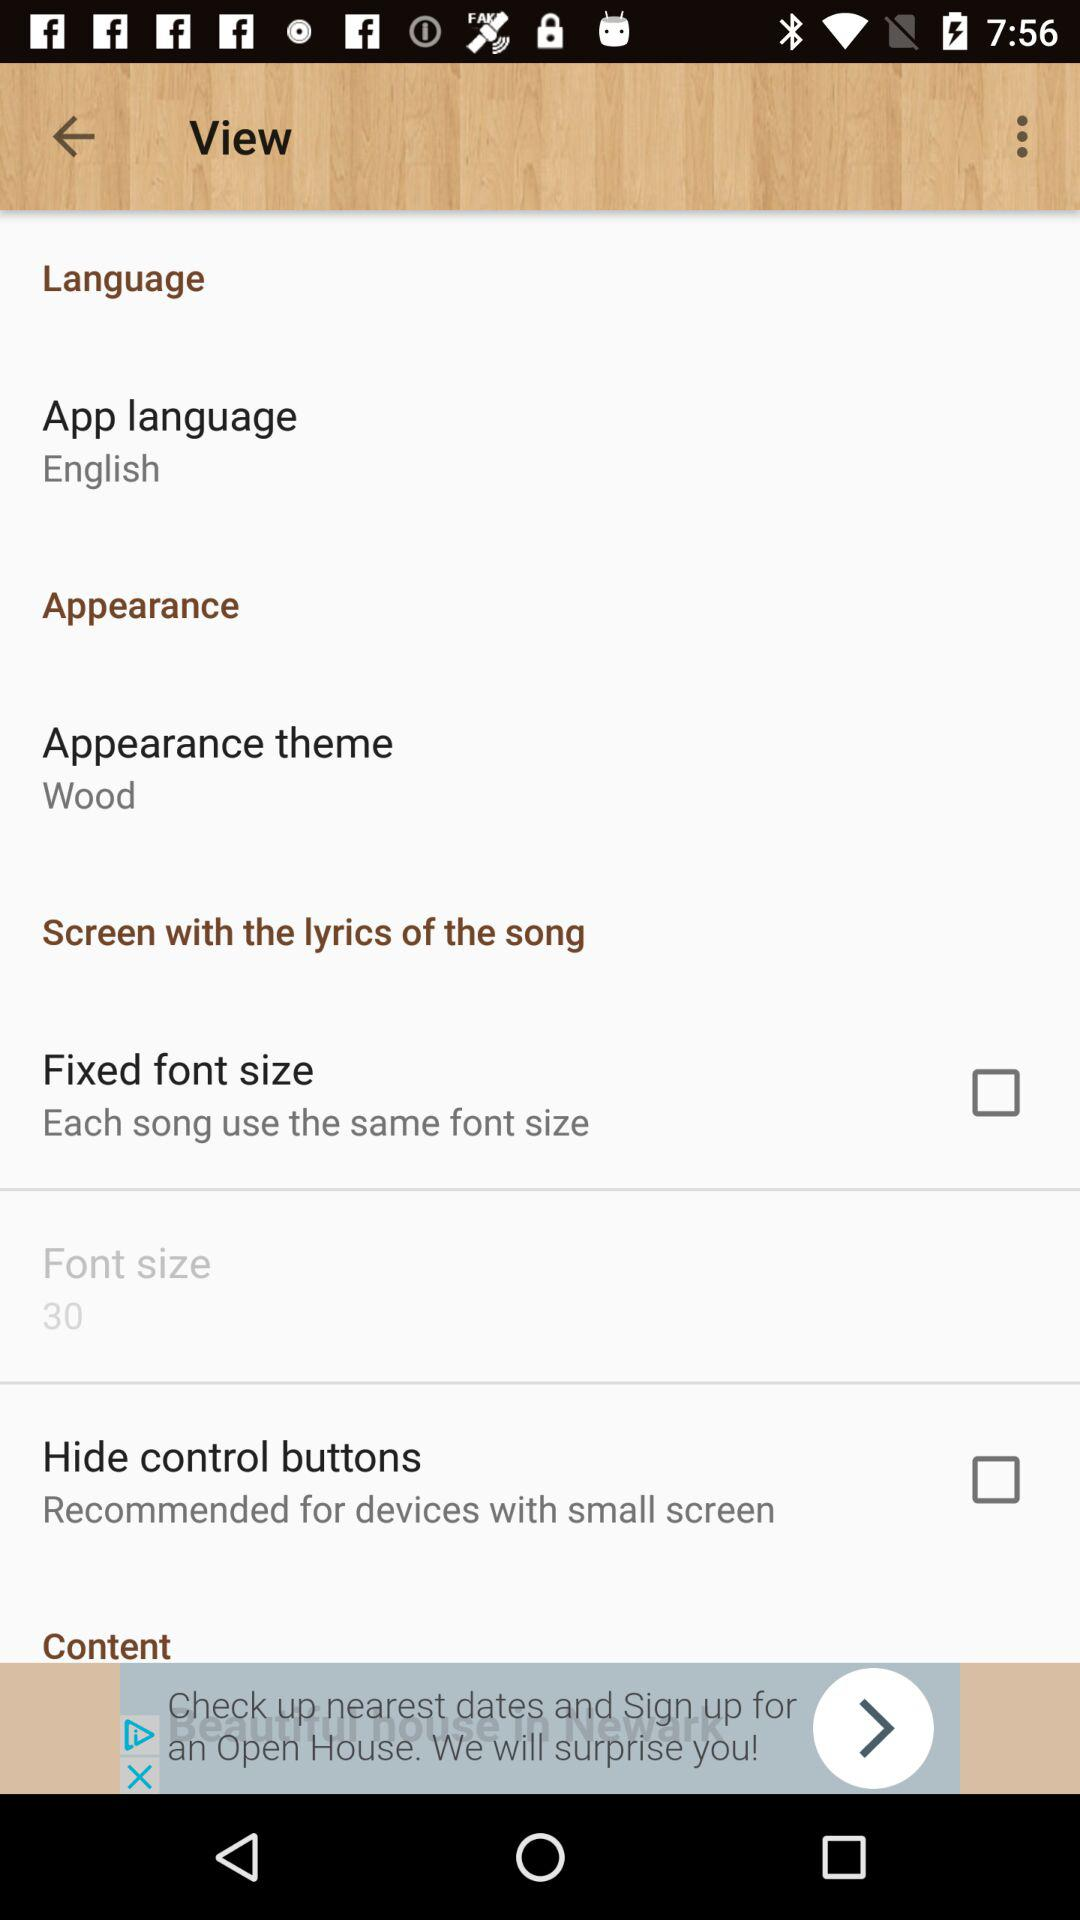What is the status of "Fixed font size"? The status is "off". 